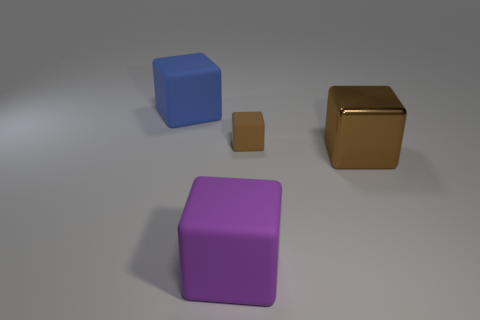Are the large object that is on the left side of the purple block and the big purple cube made of the same material?
Make the answer very short. Yes. There is a big metal block; is it the same color as the rubber thing in front of the brown metallic object?
Your answer should be very brief. No. There is a brown rubber block; are there any purple cubes to the right of it?
Give a very brief answer. No. Does the brown object behind the metal cube have the same size as the object in front of the big brown metallic block?
Give a very brief answer. No. Is there a metallic cube of the same size as the brown metal thing?
Give a very brief answer. No. Does the large matte thing that is in front of the blue object have the same shape as the tiny thing?
Give a very brief answer. Yes. There is a brown object in front of the brown matte block; what is its material?
Ensure brevity in your answer.  Metal. What shape is the matte thing that is on the right side of the big matte cube that is on the right side of the big blue cube?
Your answer should be very brief. Cube. Does the big brown shiny object have the same shape as the matte thing in front of the tiny brown rubber block?
Ensure brevity in your answer.  Yes. What number of small objects are behind the small rubber object behind the big purple thing?
Your answer should be compact. 0. 